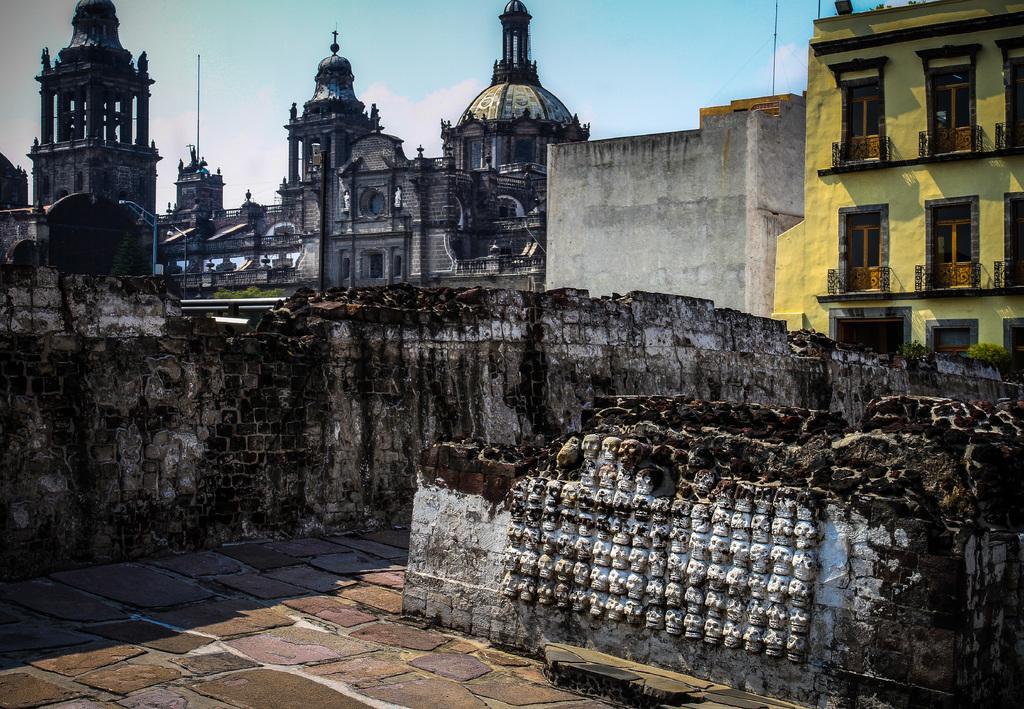Could you give a brief overview of what you see in this image? In the picture we can see a marble surface near to it, we can see some broken old walls and behind it, we can see some historical construction and besides, we can see a building which is yellow in color with some windows and in the background we can see a sky. 